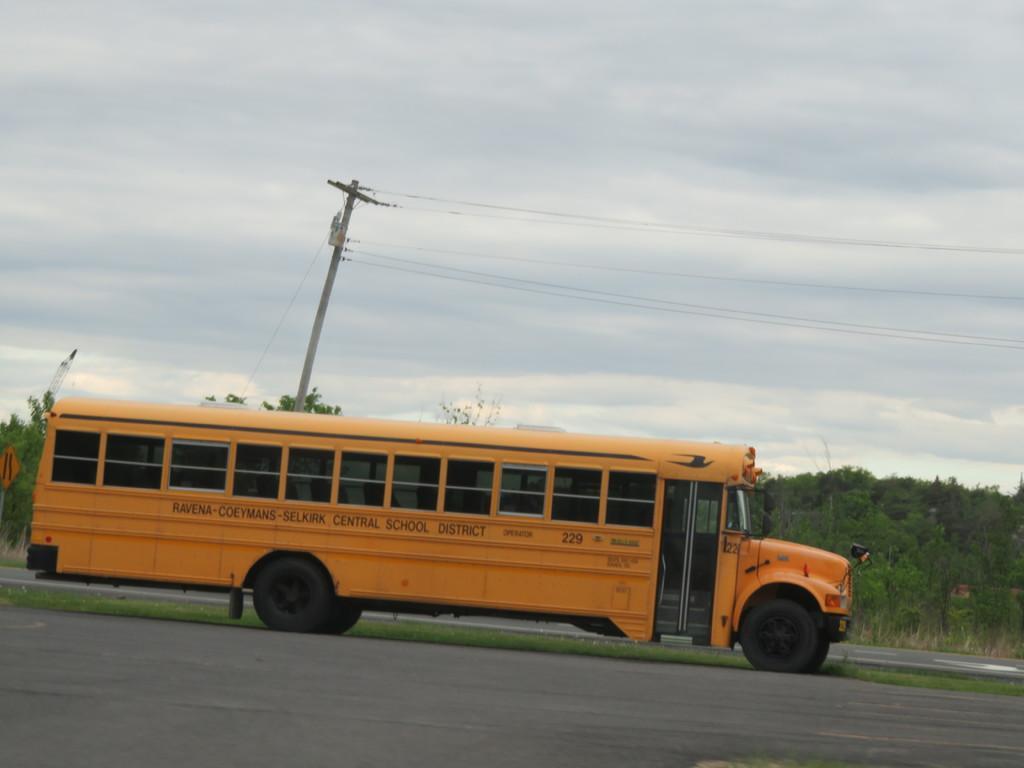How would you summarize this image in a sentence or two? In this image can see the road. I can see a vehicle with some text written on it. In the background, I can see the trees, an electric pole and clouds in the sky. 